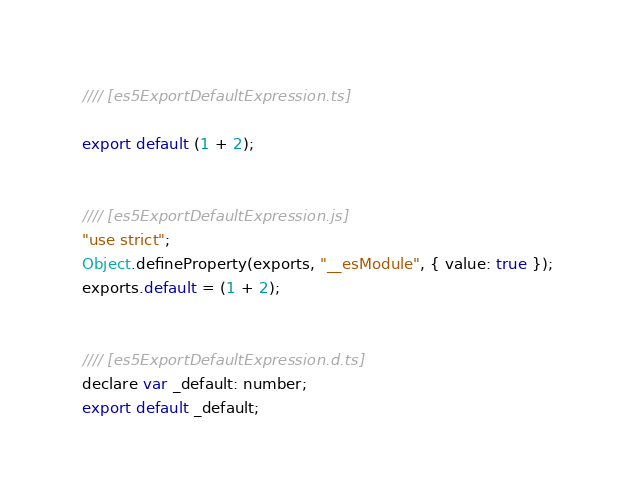<code> <loc_0><loc_0><loc_500><loc_500><_JavaScript_>//// [es5ExportDefaultExpression.ts]

export default (1 + 2);


//// [es5ExportDefaultExpression.js]
"use strict";
Object.defineProperty(exports, "__esModule", { value: true });
exports.default = (1 + 2);


//// [es5ExportDefaultExpression.d.ts]
declare var _default: number;
export default _default;
</code> 